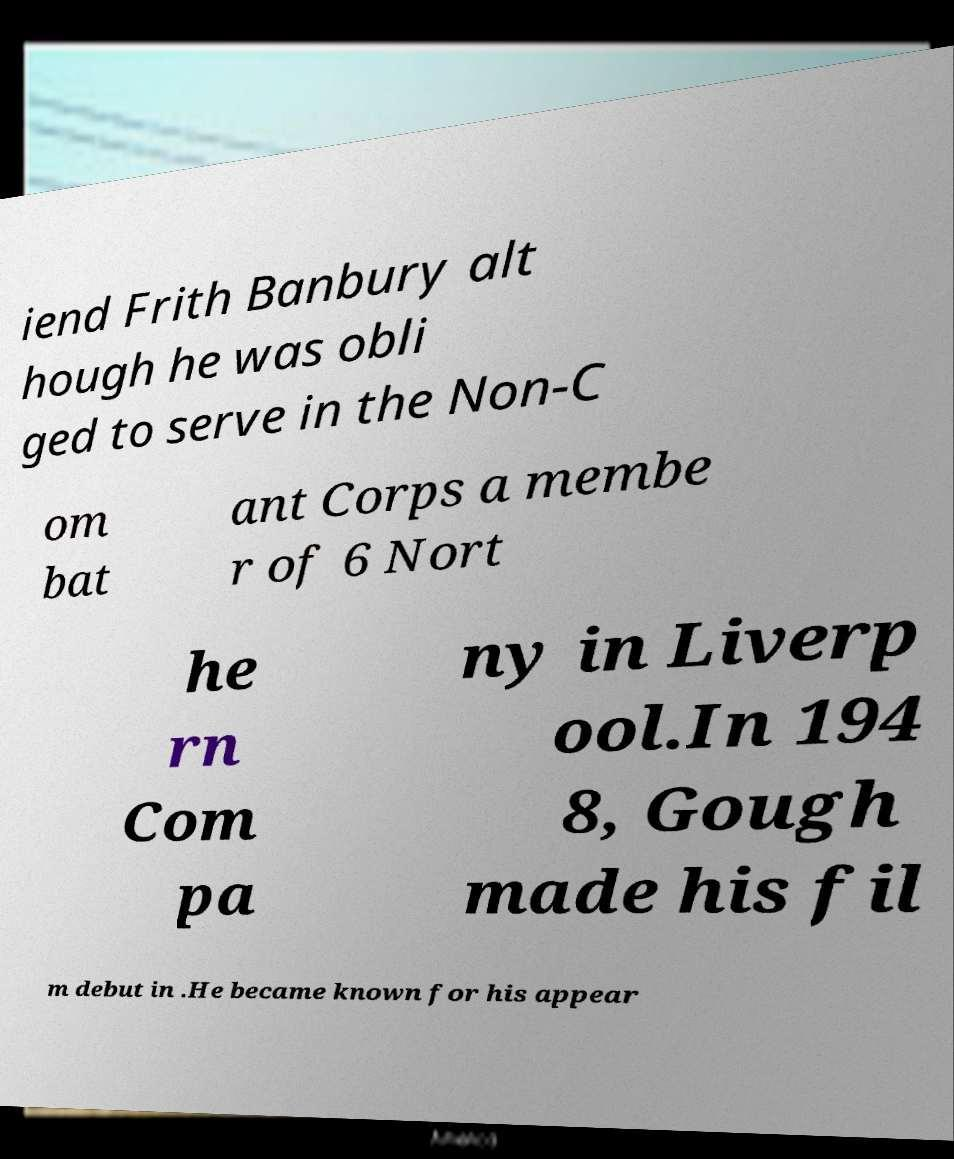For documentation purposes, I need the text within this image transcribed. Could you provide that? iend Frith Banbury alt hough he was obli ged to serve in the Non-C om bat ant Corps a membe r of 6 Nort he rn Com pa ny in Liverp ool.In 194 8, Gough made his fil m debut in .He became known for his appear 